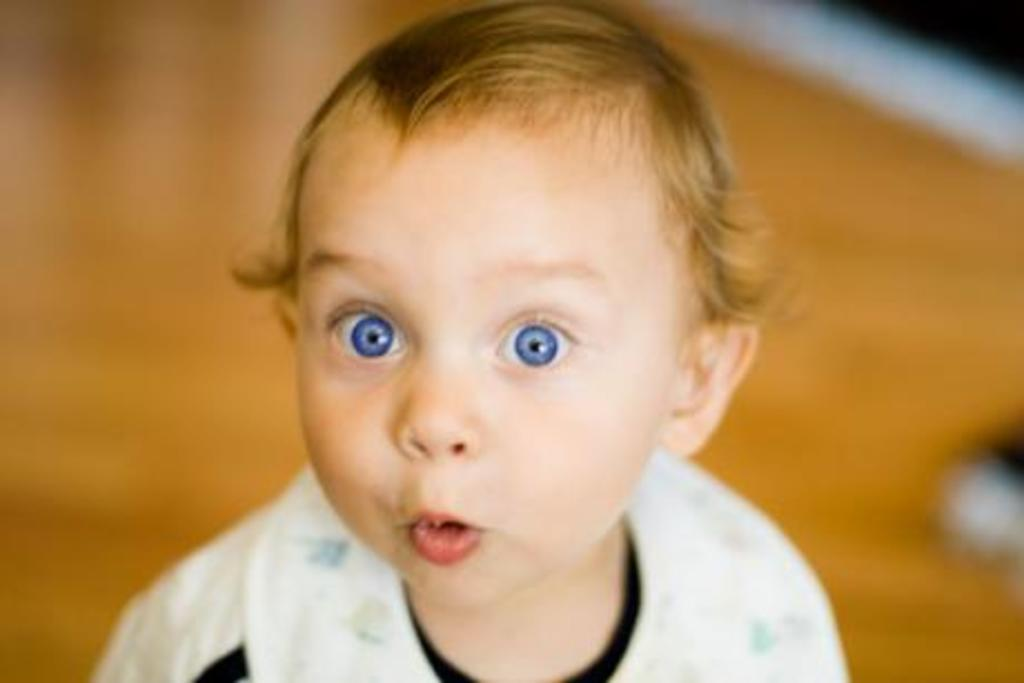What is the main subject of the image? There is a baby in the image. Can you describe the baby's features? The baby has blue eyes, golden hair, and a pouty mouth. What type of flooring is visible in the background of the image? There is a wooden floor in the background of the image. What type of ant can be seen crawling on the baby's forehead in the image? There are no ants present in the image; it only features a baby with blue eyes, golden hair, and a pouty mouth, along with a wooden floor in the background. 